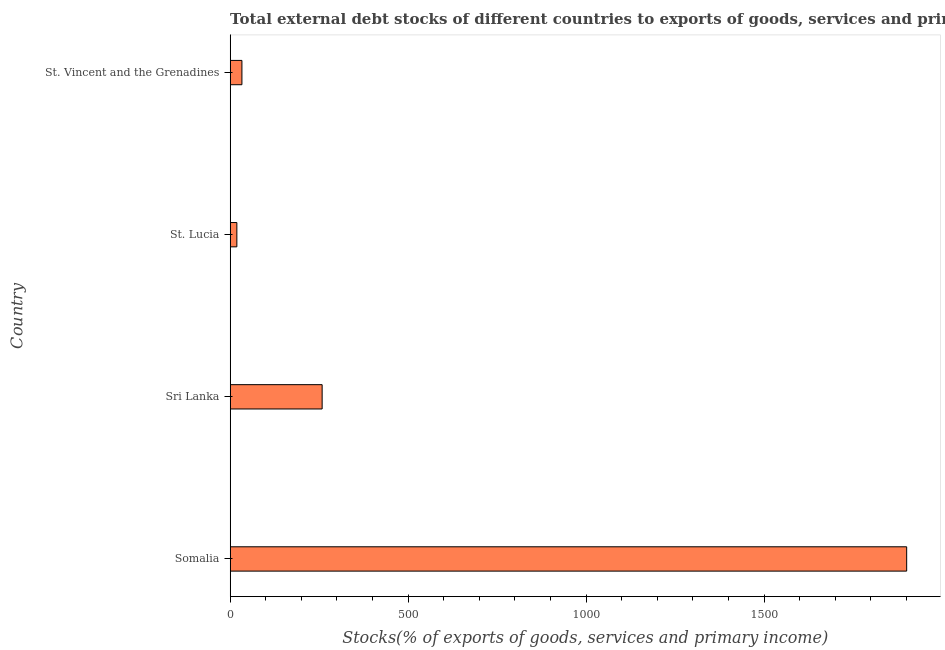Does the graph contain any zero values?
Keep it short and to the point. No. Does the graph contain grids?
Your response must be concise. No. What is the title of the graph?
Offer a very short reply. Total external debt stocks of different countries to exports of goods, services and primary income in 1986. What is the label or title of the X-axis?
Provide a succinct answer. Stocks(% of exports of goods, services and primary income). What is the label or title of the Y-axis?
Give a very brief answer. Country. What is the external debt stocks in Sri Lanka?
Keep it short and to the point. 258.35. Across all countries, what is the maximum external debt stocks?
Offer a very short reply. 1900.56. Across all countries, what is the minimum external debt stocks?
Provide a short and direct response. 18.73. In which country was the external debt stocks maximum?
Your answer should be very brief. Somalia. In which country was the external debt stocks minimum?
Provide a short and direct response. St. Lucia. What is the sum of the external debt stocks?
Ensure brevity in your answer.  2210.6. What is the difference between the external debt stocks in Somalia and Sri Lanka?
Provide a short and direct response. 1642.2. What is the average external debt stocks per country?
Keep it short and to the point. 552.65. What is the median external debt stocks?
Keep it short and to the point. 145.66. What is the ratio of the external debt stocks in Somalia to that in St. Vincent and the Grenadines?
Your answer should be very brief. 57.66. Is the difference between the external debt stocks in Somalia and St. Vincent and the Grenadines greater than the difference between any two countries?
Keep it short and to the point. No. What is the difference between the highest and the second highest external debt stocks?
Give a very brief answer. 1642.2. Is the sum of the external debt stocks in Somalia and Sri Lanka greater than the maximum external debt stocks across all countries?
Your answer should be very brief. Yes. What is the difference between the highest and the lowest external debt stocks?
Your answer should be very brief. 1881.82. In how many countries, is the external debt stocks greater than the average external debt stocks taken over all countries?
Give a very brief answer. 1. How many bars are there?
Provide a short and direct response. 4. What is the difference between two consecutive major ticks on the X-axis?
Provide a short and direct response. 500. What is the Stocks(% of exports of goods, services and primary income) of Somalia?
Provide a short and direct response. 1900.56. What is the Stocks(% of exports of goods, services and primary income) in Sri Lanka?
Offer a terse response. 258.35. What is the Stocks(% of exports of goods, services and primary income) in St. Lucia?
Offer a very short reply. 18.73. What is the Stocks(% of exports of goods, services and primary income) in St. Vincent and the Grenadines?
Provide a short and direct response. 32.96. What is the difference between the Stocks(% of exports of goods, services and primary income) in Somalia and Sri Lanka?
Provide a short and direct response. 1642.2. What is the difference between the Stocks(% of exports of goods, services and primary income) in Somalia and St. Lucia?
Offer a terse response. 1881.82. What is the difference between the Stocks(% of exports of goods, services and primary income) in Somalia and St. Vincent and the Grenadines?
Offer a terse response. 1867.59. What is the difference between the Stocks(% of exports of goods, services and primary income) in Sri Lanka and St. Lucia?
Keep it short and to the point. 239.62. What is the difference between the Stocks(% of exports of goods, services and primary income) in Sri Lanka and St. Vincent and the Grenadines?
Keep it short and to the point. 225.39. What is the difference between the Stocks(% of exports of goods, services and primary income) in St. Lucia and St. Vincent and the Grenadines?
Your response must be concise. -14.23. What is the ratio of the Stocks(% of exports of goods, services and primary income) in Somalia to that in Sri Lanka?
Ensure brevity in your answer.  7.36. What is the ratio of the Stocks(% of exports of goods, services and primary income) in Somalia to that in St. Lucia?
Keep it short and to the point. 101.46. What is the ratio of the Stocks(% of exports of goods, services and primary income) in Somalia to that in St. Vincent and the Grenadines?
Give a very brief answer. 57.66. What is the ratio of the Stocks(% of exports of goods, services and primary income) in Sri Lanka to that in St. Lucia?
Provide a succinct answer. 13.79. What is the ratio of the Stocks(% of exports of goods, services and primary income) in Sri Lanka to that in St. Vincent and the Grenadines?
Make the answer very short. 7.84. What is the ratio of the Stocks(% of exports of goods, services and primary income) in St. Lucia to that in St. Vincent and the Grenadines?
Provide a succinct answer. 0.57. 